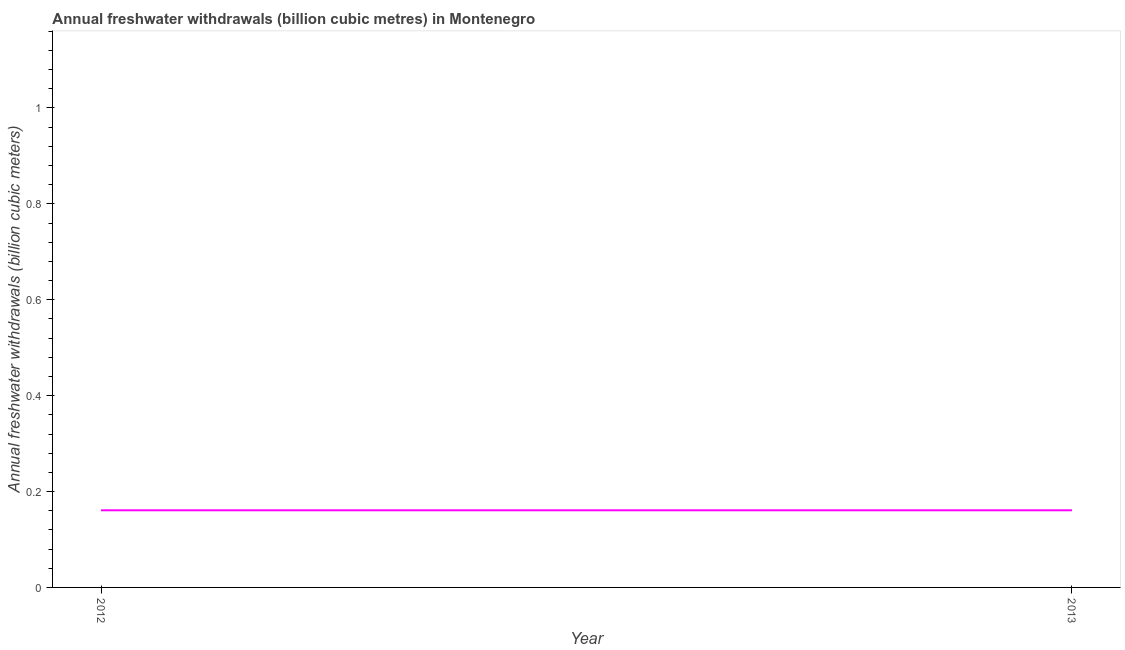What is the annual freshwater withdrawals in 2013?
Your response must be concise. 0.16. Across all years, what is the maximum annual freshwater withdrawals?
Provide a succinct answer. 0.16. Across all years, what is the minimum annual freshwater withdrawals?
Your response must be concise. 0.16. What is the sum of the annual freshwater withdrawals?
Offer a very short reply. 0.32. What is the difference between the annual freshwater withdrawals in 2012 and 2013?
Provide a short and direct response. 0. What is the average annual freshwater withdrawals per year?
Offer a terse response. 0.16. What is the median annual freshwater withdrawals?
Give a very brief answer. 0.16. In how many years, is the annual freshwater withdrawals greater than 0.24000000000000002 billion cubic meters?
Provide a succinct answer. 0. Does the annual freshwater withdrawals monotonically increase over the years?
Offer a very short reply. No. How many years are there in the graph?
Ensure brevity in your answer.  2. What is the title of the graph?
Offer a very short reply. Annual freshwater withdrawals (billion cubic metres) in Montenegro. What is the label or title of the Y-axis?
Provide a succinct answer. Annual freshwater withdrawals (billion cubic meters). What is the Annual freshwater withdrawals (billion cubic meters) in 2012?
Keep it short and to the point. 0.16. What is the Annual freshwater withdrawals (billion cubic meters) of 2013?
Provide a short and direct response. 0.16. What is the difference between the Annual freshwater withdrawals (billion cubic meters) in 2012 and 2013?
Provide a short and direct response. 0. What is the ratio of the Annual freshwater withdrawals (billion cubic meters) in 2012 to that in 2013?
Provide a succinct answer. 1. 